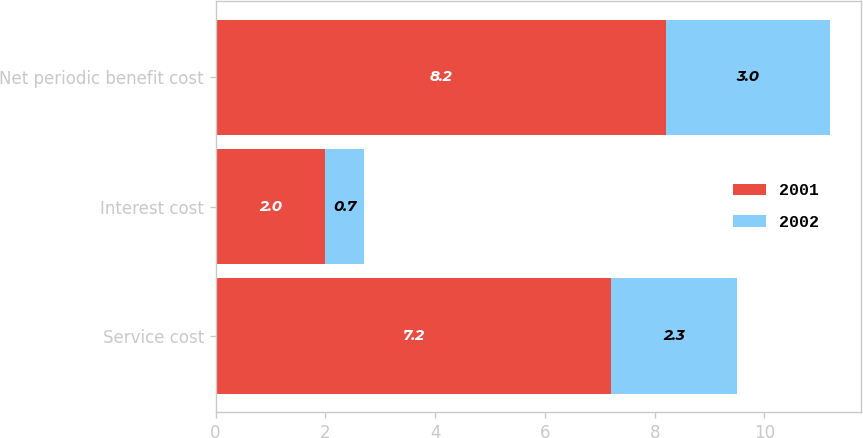<chart> <loc_0><loc_0><loc_500><loc_500><stacked_bar_chart><ecel><fcel>Service cost<fcel>Interest cost<fcel>Net periodic benefit cost<nl><fcel>2001<fcel>7.2<fcel>2<fcel>8.2<nl><fcel>2002<fcel>2.3<fcel>0.7<fcel>3<nl></chart> 